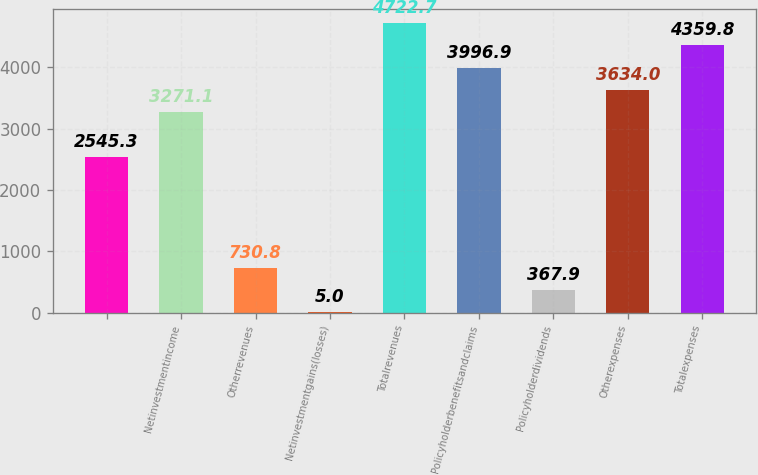Convert chart. <chart><loc_0><loc_0><loc_500><loc_500><bar_chart><ecel><fcel>Netinvestmentincome<fcel>Otherrevenues<fcel>Netinvestmentgains(losses)<fcel>Totalrevenues<fcel>Policyholderbenefitsandclaims<fcel>Policyholderdividends<fcel>Otherexpenses<fcel>Totalexpenses<nl><fcel>2545.3<fcel>3271.1<fcel>730.8<fcel>5<fcel>4722.7<fcel>3996.9<fcel>367.9<fcel>3634<fcel>4359.8<nl></chart> 